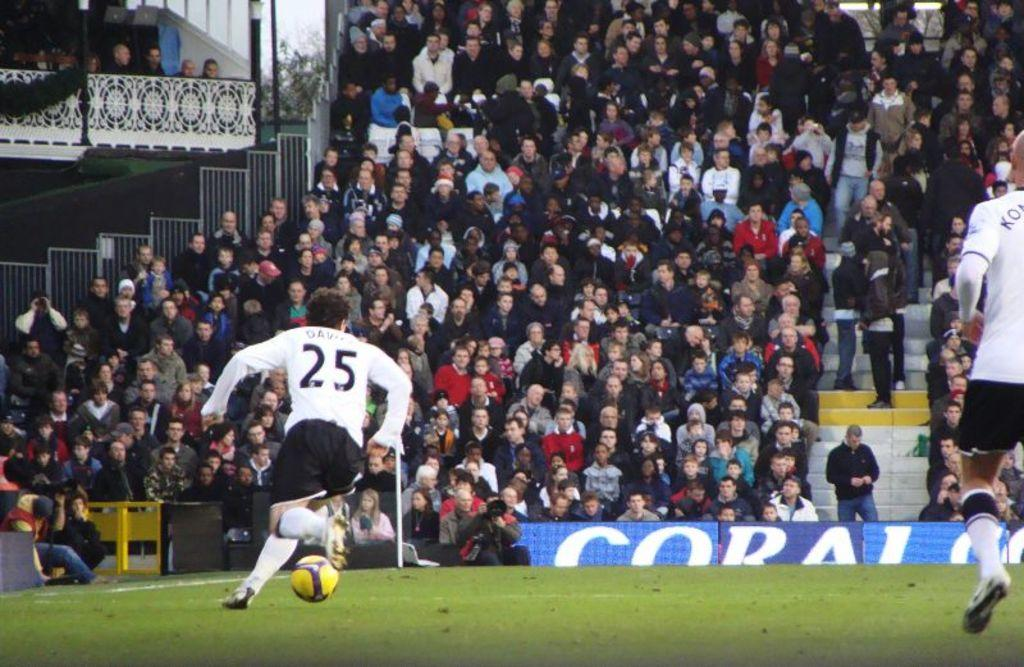<image>
Present a compact description of the photo's key features. Player number 25 currently has the soccer ball and is running with it. 